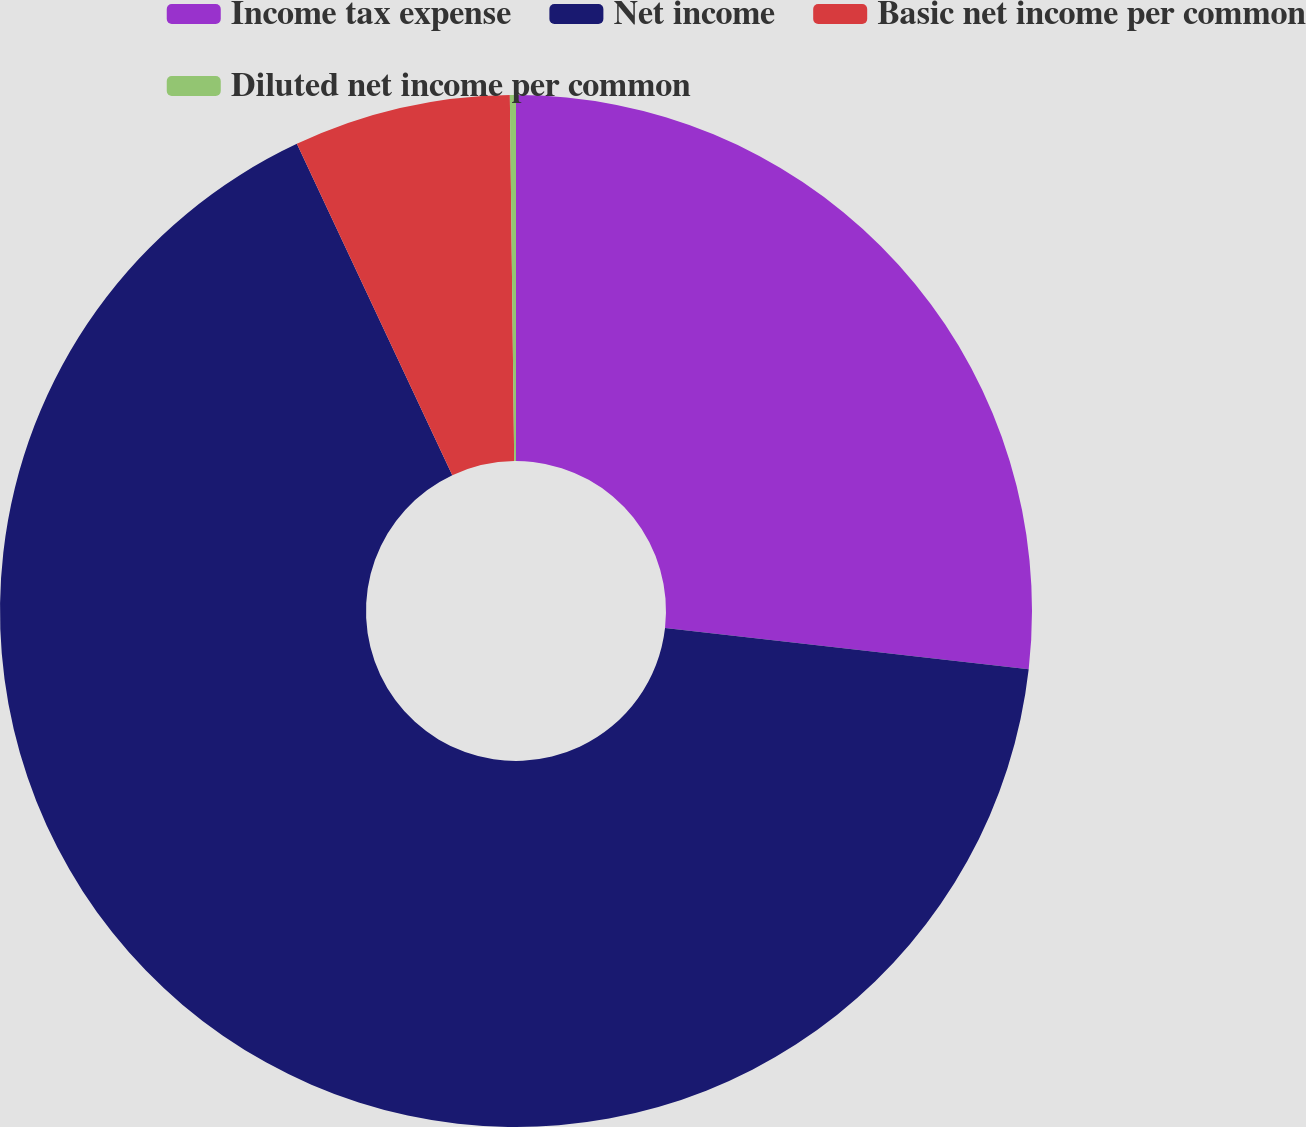Convert chart. <chart><loc_0><loc_0><loc_500><loc_500><pie_chart><fcel>Income tax expense<fcel>Net income<fcel>Basic net income per common<fcel>Diluted net income per common<nl><fcel>26.8%<fcel>66.21%<fcel>6.79%<fcel>0.19%<nl></chart> 